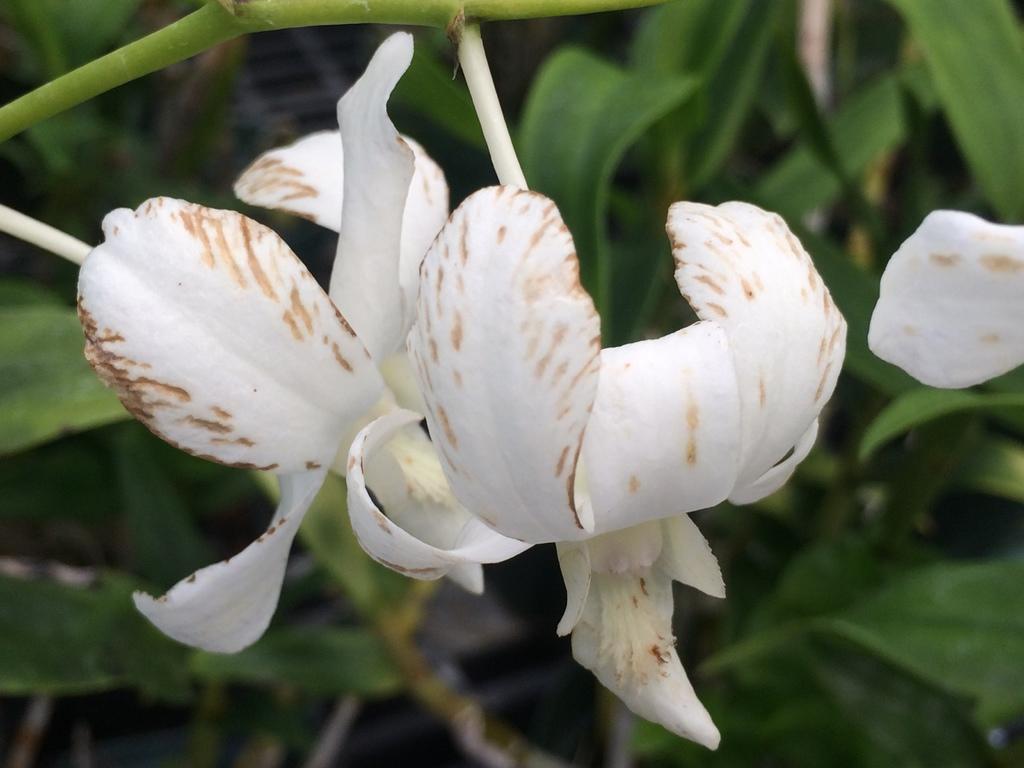How would you summarize this image in a sentence or two? In this image I see the flowers which are of white in color and I see the stem over here and in the background I see the green leaves. 